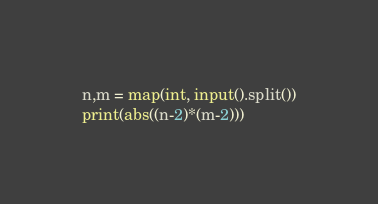<code> <loc_0><loc_0><loc_500><loc_500><_Python_>n,m = map(int, input().split())
print(abs((n-2)*(m-2)))</code> 